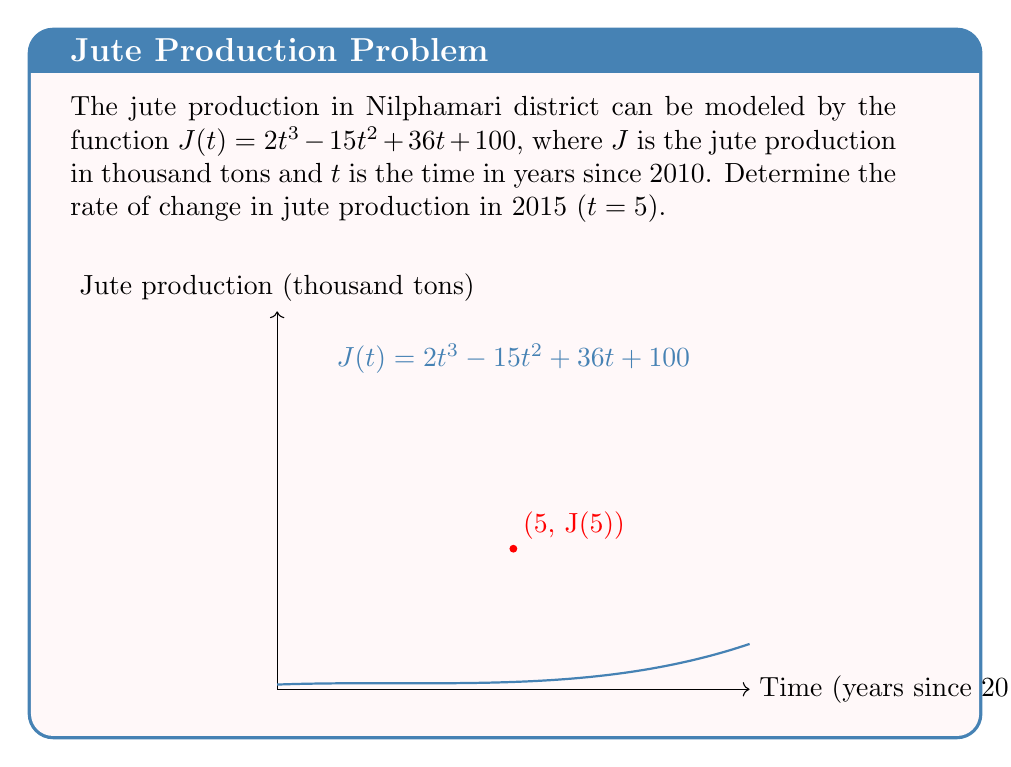Show me your answer to this math problem. To find the rate of change in jute production, we need to calculate the derivative of $J(t)$ and evaluate it at $t = 5$. Let's break this down step-by-step:

1) First, let's find $J'(t)$ using the power rule:
   $$J'(t) = \frac{d}{dt}(2t^3 - 15t^2 + 36t + 100)$$
   $$J'(t) = 6t^2 - 30t + 36$$

2) Now, we need to evaluate $J'(5)$:
   $$J'(5) = 6(5)^2 - 30(5) + 36$$
   $$J'(5) = 6(25) - 150 + 36$$
   $$J'(5) = 150 - 150 + 36$$
   $$J'(5) = 36$$

3) Interpret the result:
   The rate of change of jute production in 2015 (when t = 5) is 36 thousand tons per year.

Note: The positive value indicates that jute production was increasing in 2015.
Answer: $36$ thousand tons per year 